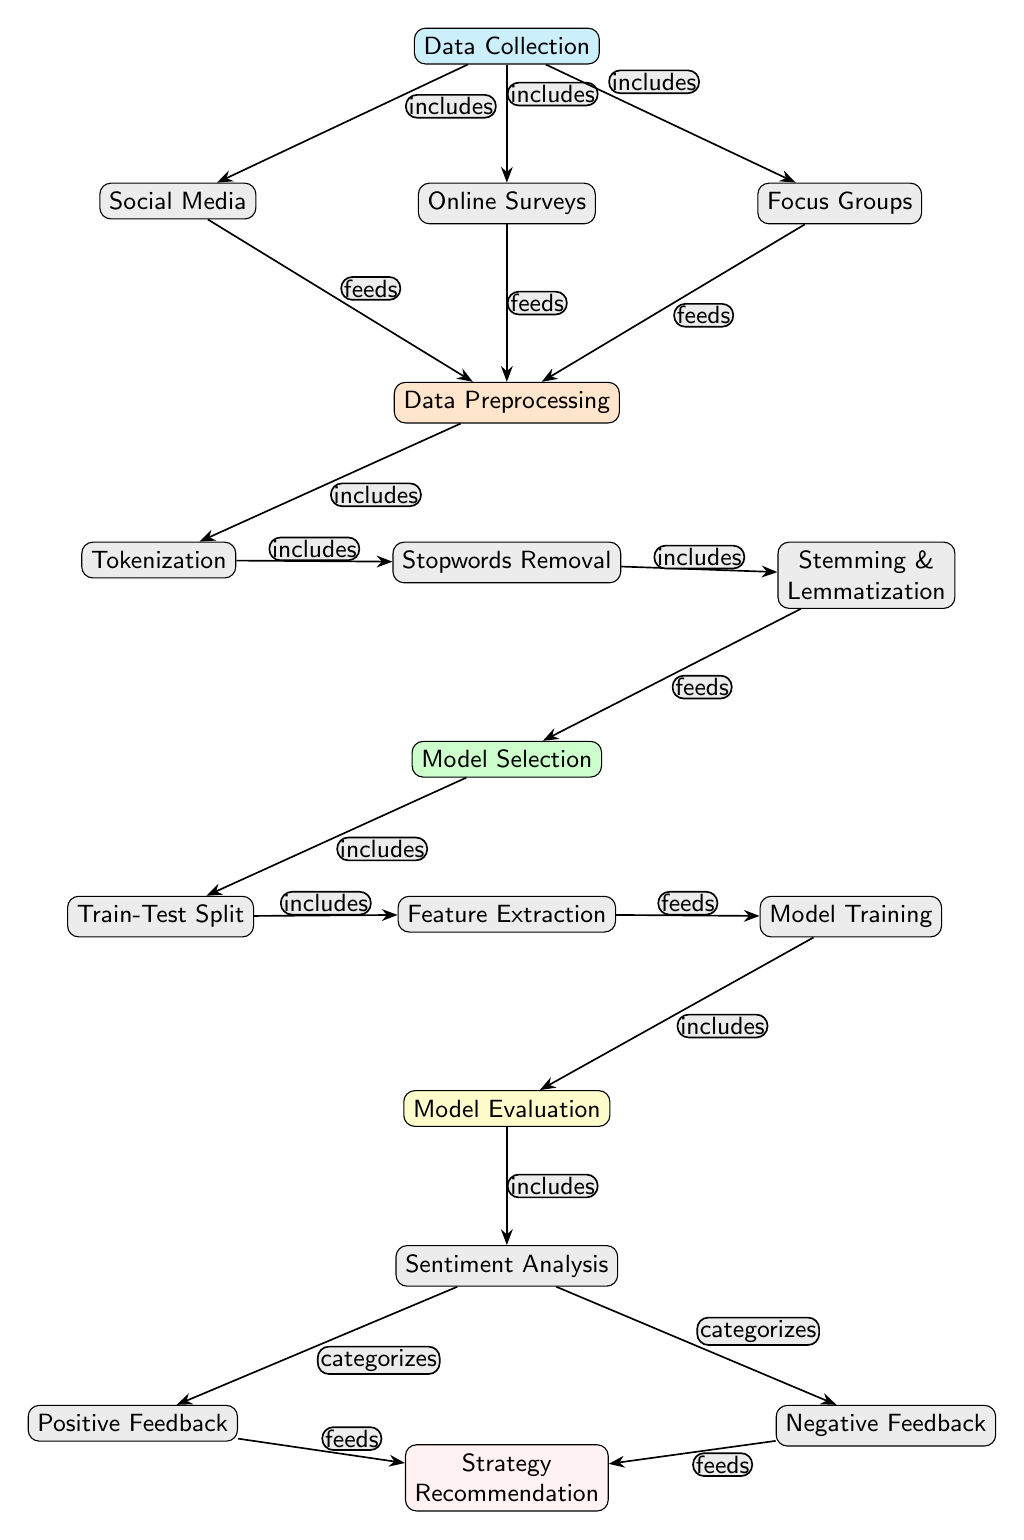What are the sources of data collection in the diagram? The diagram lists three sources of data collection: social media, online surveys, and focus groups. These nodes are directly connected to the data collection node, indicating their roles in gathering feedback.
Answer: social media, online surveys, focus groups What step comes after data preprocessing? According to the flow of the diagram, after data preprocessing, the next step is model selection. This is indicated by the directed edge connecting the preprocessing node to the model selection node.
Answer: model selection How many nodes are in the sentiment analysis section? In the sentiment analysis section, there are three nodes: sentiment analysis, positive feedback, and negative feedback. This can be counted directly from the diagram under the model evaluation node.
Answer: three Which node categorizes feedback? The sentiment analysis node is where the categorization of feedback occurs according to the diagram. This is indicated by the directed edges leading to the positive feedback and negative feedback nodes.
Answer: sentiment analysis What is the final outcome listed in the diagram? The final outcome is strategy recommendation, which is the last node in the flow following the analysis of positive and negative feedback. This is derived from the edges fed by those feedback nodes.
Answer: strategy recommendation What processes are involved in data preprocessing? In data preprocessing, the diagram includes the processes of tokenization, stopwords removal, stemming, and lemmatization. These are clearly listed as sub-nodes under the preprocessing node.
Answer: tokenization, stopwords removal, stemming & lemmatization Which phase involves splitting the data? The train-test split phase is responsible for dividing the dataset, and it is listed as a sub-process within the model selection node in the diagram.
Answer: train-test split How does feedback reach the strategy recommendation? Feedback reaches the strategy recommendation through the sentiment analysis node, which categorizes it into positive and negative feedback nodes, both of which feed into the strategy node. This highlights the feedback's journey through multiple steps in the process.
Answer: positive feedback, negative feedback 